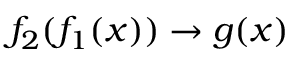Convert formula to latex. <formula><loc_0><loc_0><loc_500><loc_500>f _ { 2 } ( f _ { 1 } ( x ) ) \rightarrow g ( x )</formula> 